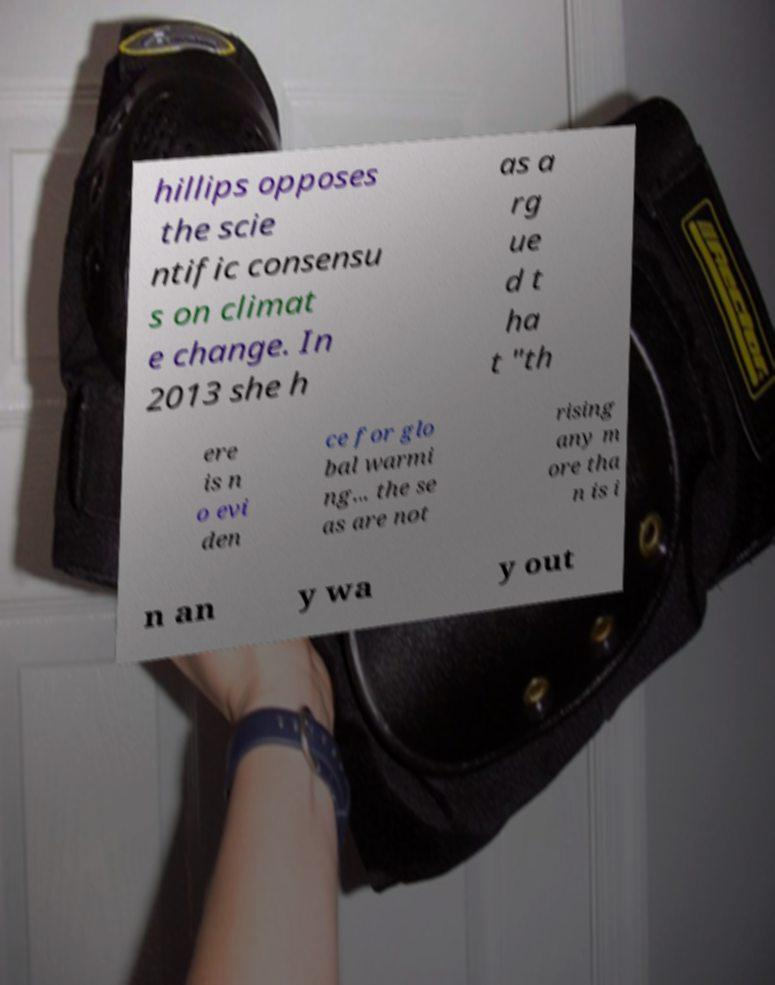Please identify and transcribe the text found in this image. hillips opposes the scie ntific consensu s on climat e change. In 2013 she h as a rg ue d t ha t "th ere is n o evi den ce for glo bal warmi ng... the se as are not rising any m ore tha n is i n an y wa y out 